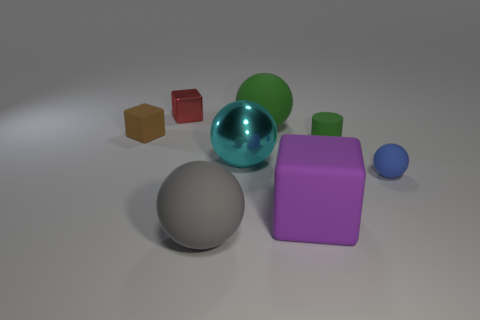There is a green sphere that is made of the same material as the gray object; what is its size?
Give a very brief answer. Large. How big is the ball in front of the block right of the tiny red shiny block?
Give a very brief answer. Large. What size is the block that is right of the large ball in front of the matte sphere that is to the right of the big purple object?
Provide a succinct answer. Large. Are there more tiny green objects that are on the right side of the small red metallic object than big green cylinders?
Offer a very short reply. Yes. Is there a small metallic object of the same shape as the brown rubber object?
Make the answer very short. Yes. Do the brown block and the block right of the metallic block have the same material?
Keep it short and to the point. Yes. The small ball is what color?
Offer a very short reply. Blue. What number of small matte cylinders are right of the metallic object right of the large gray thing on the left side of the purple matte thing?
Provide a succinct answer. 1. Are there any big things left of the large rubber cube?
Your answer should be compact. Yes. What number of brown blocks are made of the same material as the big gray object?
Ensure brevity in your answer.  1. 